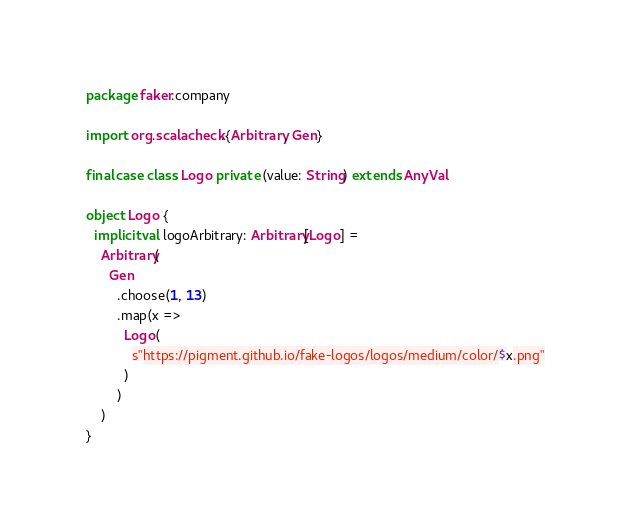<code> <loc_0><loc_0><loc_500><loc_500><_Scala_>package faker.company

import org.scalacheck.{Arbitrary, Gen}

final case class Logo private (value: String) extends AnyVal

object Logo {
  implicit val logoArbitrary: Arbitrary[Logo] =
    Arbitrary(
      Gen
        .choose(1, 13)
        .map(x =>
          Logo(
            s"https://pigment.github.io/fake-logos/logos/medium/color/$x.png"
          )
        )
    )
}
</code> 